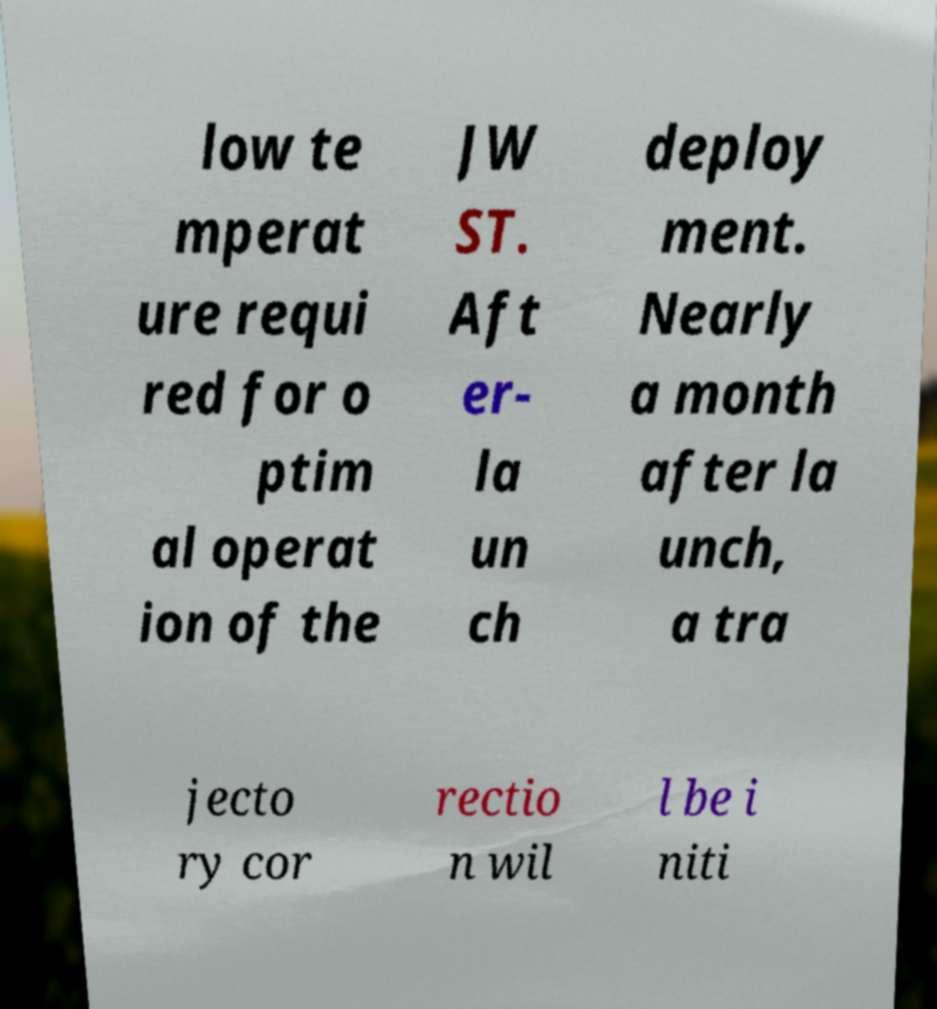What messages or text are displayed in this image? I need them in a readable, typed format. low te mperat ure requi red for o ptim al operat ion of the JW ST. Aft er- la un ch deploy ment. Nearly a month after la unch, a tra jecto ry cor rectio n wil l be i niti 